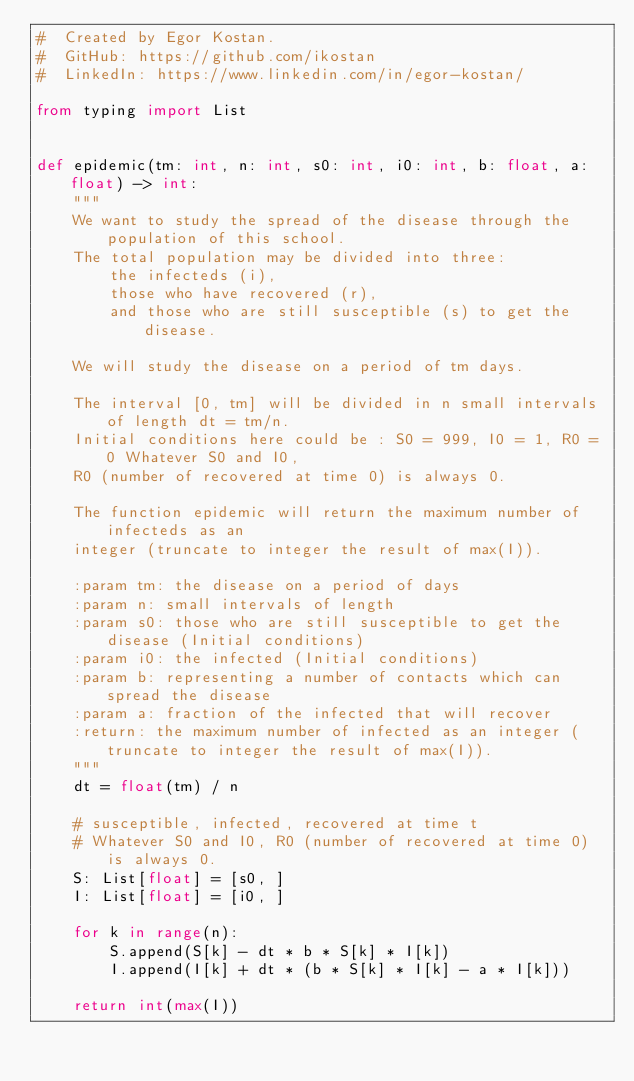Convert code to text. <code><loc_0><loc_0><loc_500><loc_500><_Python_>#  Created by Egor Kostan.
#  GitHub: https://github.com/ikostan
#  LinkedIn: https://www.linkedin.com/in/egor-kostan/

from typing import List


def epidemic(tm: int, n: int, s0: int, i0: int, b: float, a: float) -> int:
    """
    We want to study the spread of the disease through the population of this school.
    The total population may be divided into three:
        the infecteds (i),
        those who have recovered (r),
        and those who are still susceptible (s) to get the disease.

    We will study the disease on a period of tm days.

    The interval [0, tm] will be divided in n small intervals of length dt = tm/n.
    Initial conditions here could be : S0 = 999, I0 = 1, R0 = 0 Whatever S0 and I0,
    R0 (number of recovered at time 0) is always 0.

    The function epidemic will return the maximum number of infecteds as an
    integer (truncate to integer the result of max(I)).

    :param tm: the disease on a period of days
    :param n: small intervals of length
    :param s0: those who are still susceptible to get the disease (Initial conditions)
    :param i0: the infected (Initial conditions)
    :param b: representing a number of contacts which can spread the disease
    :param a: fraction of the infected that will recover
    :return: the maximum number of infected as an integer (truncate to integer the result of max(I)).
    """
    dt = float(tm) / n

    # susceptible, infected, recovered at time t
    # Whatever S0 and I0, R0 (number of recovered at time 0) is always 0.
    S: List[float] = [s0, ]
    I: List[float] = [i0, ]

    for k in range(n):
        S.append(S[k] - dt * b * S[k] * I[k])
        I.append(I[k] + dt * (b * S[k] * I[k] - a * I[k]))

    return int(max(I))
</code> 